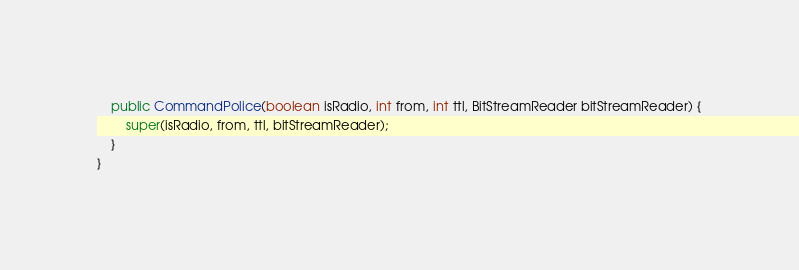<code> <loc_0><loc_0><loc_500><loc_500><_Java_>
	public CommandPolice(boolean isRadio, int from, int ttl, BitStreamReader bitStreamReader) {
		super(isRadio, from, ttl, bitStreamReader);
	}
}
</code> 